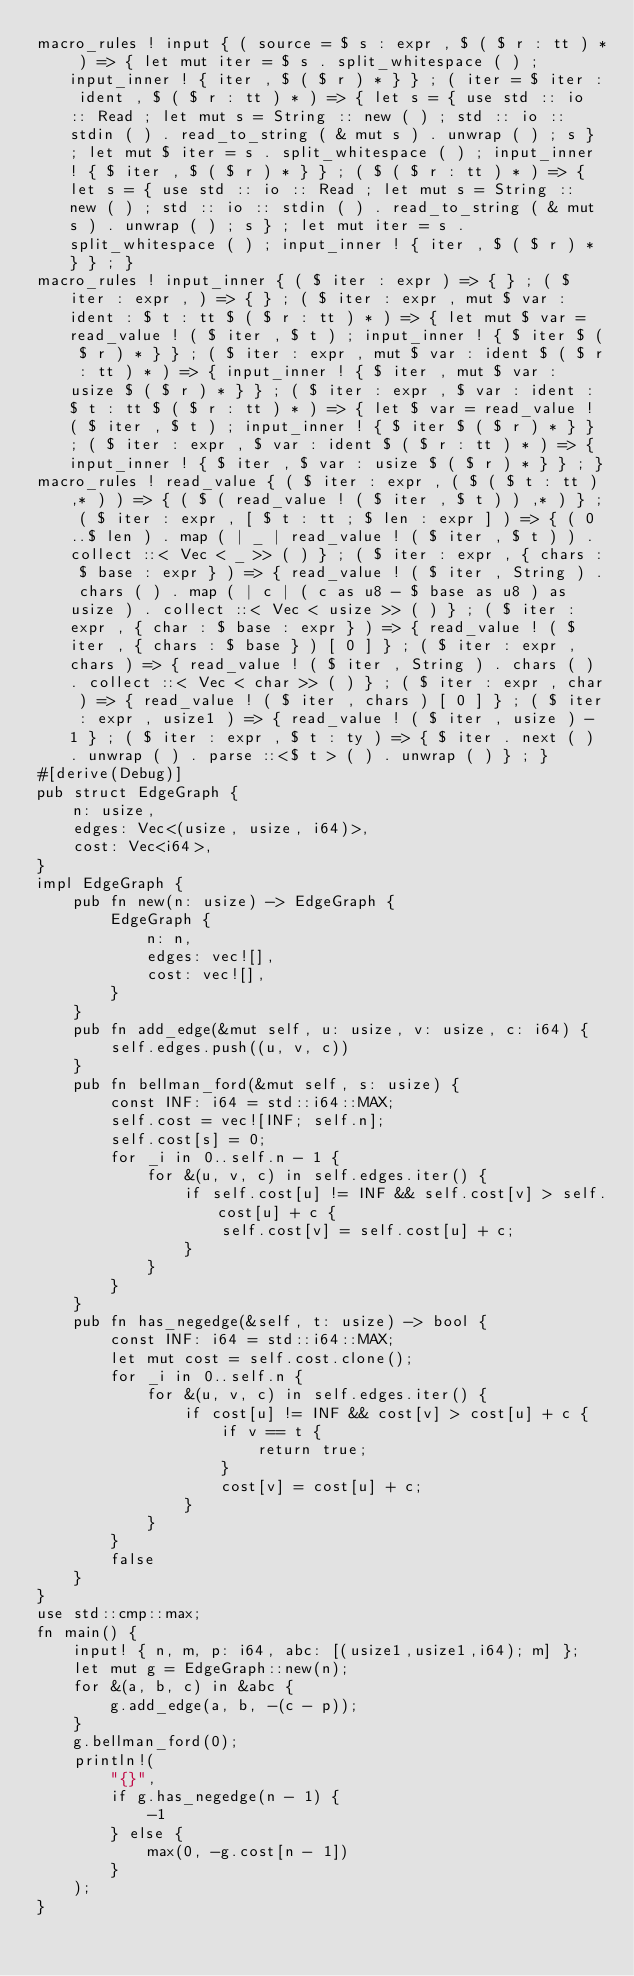Convert code to text. <code><loc_0><loc_0><loc_500><loc_500><_Rust_>macro_rules ! input { ( source = $ s : expr , $ ( $ r : tt ) * ) => { let mut iter = $ s . split_whitespace ( ) ; input_inner ! { iter , $ ( $ r ) * } } ; ( iter = $ iter : ident , $ ( $ r : tt ) * ) => { let s = { use std :: io :: Read ; let mut s = String :: new ( ) ; std :: io :: stdin ( ) . read_to_string ( & mut s ) . unwrap ( ) ; s } ; let mut $ iter = s . split_whitespace ( ) ; input_inner ! { $ iter , $ ( $ r ) * } } ; ( $ ( $ r : tt ) * ) => { let s = { use std :: io :: Read ; let mut s = String :: new ( ) ; std :: io :: stdin ( ) . read_to_string ( & mut s ) . unwrap ( ) ; s } ; let mut iter = s . split_whitespace ( ) ; input_inner ! { iter , $ ( $ r ) * } } ; }
macro_rules ! input_inner { ( $ iter : expr ) => { } ; ( $ iter : expr , ) => { } ; ( $ iter : expr , mut $ var : ident : $ t : tt $ ( $ r : tt ) * ) => { let mut $ var = read_value ! ( $ iter , $ t ) ; input_inner ! { $ iter $ ( $ r ) * } } ; ( $ iter : expr , mut $ var : ident $ ( $ r : tt ) * ) => { input_inner ! { $ iter , mut $ var : usize $ ( $ r ) * } } ; ( $ iter : expr , $ var : ident : $ t : tt $ ( $ r : tt ) * ) => { let $ var = read_value ! ( $ iter , $ t ) ; input_inner ! { $ iter $ ( $ r ) * } } ; ( $ iter : expr , $ var : ident $ ( $ r : tt ) * ) => { input_inner ! { $ iter , $ var : usize $ ( $ r ) * } } ; }
macro_rules ! read_value { ( $ iter : expr , ( $ ( $ t : tt ) ,* ) ) => { ( $ ( read_value ! ( $ iter , $ t ) ) ,* ) } ; ( $ iter : expr , [ $ t : tt ; $ len : expr ] ) => { ( 0 ..$ len ) . map ( | _ | read_value ! ( $ iter , $ t ) ) . collect ::< Vec < _ >> ( ) } ; ( $ iter : expr , { chars : $ base : expr } ) => { read_value ! ( $ iter , String ) . chars ( ) . map ( | c | ( c as u8 - $ base as u8 ) as usize ) . collect ::< Vec < usize >> ( ) } ; ( $ iter : expr , { char : $ base : expr } ) => { read_value ! ( $ iter , { chars : $ base } ) [ 0 ] } ; ( $ iter : expr , chars ) => { read_value ! ( $ iter , String ) . chars ( ) . collect ::< Vec < char >> ( ) } ; ( $ iter : expr , char ) => { read_value ! ( $ iter , chars ) [ 0 ] } ; ( $ iter : expr , usize1 ) => { read_value ! ( $ iter , usize ) - 1 } ; ( $ iter : expr , $ t : ty ) => { $ iter . next ( ) . unwrap ( ) . parse ::<$ t > ( ) . unwrap ( ) } ; }
#[derive(Debug)]
pub struct EdgeGraph {
    n: usize,
    edges: Vec<(usize, usize, i64)>,
    cost: Vec<i64>,
}
impl EdgeGraph {
    pub fn new(n: usize) -> EdgeGraph {
        EdgeGraph {
            n: n,
            edges: vec![],
            cost: vec![],
        }
    }
    pub fn add_edge(&mut self, u: usize, v: usize, c: i64) {
        self.edges.push((u, v, c))
    }
    pub fn bellman_ford(&mut self, s: usize) {
        const INF: i64 = std::i64::MAX;
        self.cost = vec![INF; self.n];
        self.cost[s] = 0;
        for _i in 0..self.n - 1 {
            for &(u, v, c) in self.edges.iter() {
                if self.cost[u] != INF && self.cost[v] > self.cost[u] + c {
                    self.cost[v] = self.cost[u] + c;
                }
            }
        }
    }
    pub fn has_negedge(&self, t: usize) -> bool {
        const INF: i64 = std::i64::MAX;
        let mut cost = self.cost.clone();
        for _i in 0..self.n {
            for &(u, v, c) in self.edges.iter() {
                if cost[u] != INF && cost[v] > cost[u] + c {
                    if v == t {
                        return true;
                    }
                    cost[v] = cost[u] + c;
                }
            }
        }
        false
    }
}
use std::cmp::max;
fn main() {
    input! { n, m, p: i64, abc: [(usize1,usize1,i64); m] };
    let mut g = EdgeGraph::new(n);
    for &(a, b, c) in &abc {
        g.add_edge(a, b, -(c - p));
    }
    g.bellman_ford(0);
    println!(
        "{}",
        if g.has_negedge(n - 1) {
            -1
        } else {
            max(0, -g.cost[n - 1])
        }
    );
}
</code> 